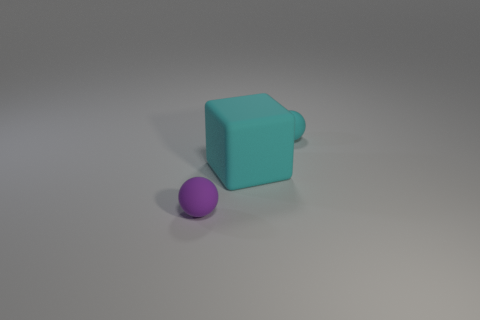There is a rubber thing that is on the left side of the small cyan matte ball and right of the small purple rubber ball; what is its color?
Offer a very short reply. Cyan. What number of spheres are either cyan rubber objects or tiny blue metallic things?
Make the answer very short. 1. Is the number of objects that are in front of the small purple thing less than the number of small blue cylinders?
Make the answer very short. No. There is a purple object that is the same material as the tiny cyan ball; what shape is it?
Ensure brevity in your answer.  Sphere. What number of large objects have the same color as the rubber cube?
Keep it short and to the point. 0. How many objects are blocks or matte balls?
Give a very brief answer. 3. What is the material of the tiny object that is behind the tiny matte ball left of the large thing?
Your answer should be very brief. Rubber. Is there a large gray ball made of the same material as the purple object?
Provide a short and direct response. No. The small matte thing on the left side of the sphere to the right of the matte ball to the left of the cyan matte block is what shape?
Make the answer very short. Sphere. What is the material of the small purple object?
Your answer should be very brief. Rubber. 